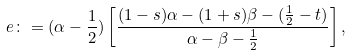<formula> <loc_0><loc_0><loc_500><loc_500>e \colon = ( \alpha - \frac { 1 } { 2 } ) \left [ \frac { ( 1 - s ) \alpha - ( 1 + s ) \beta - ( \frac { 1 } { 2 } - t ) } { \alpha - \beta - \frac { 1 } { 2 } } \right ] ,</formula> 